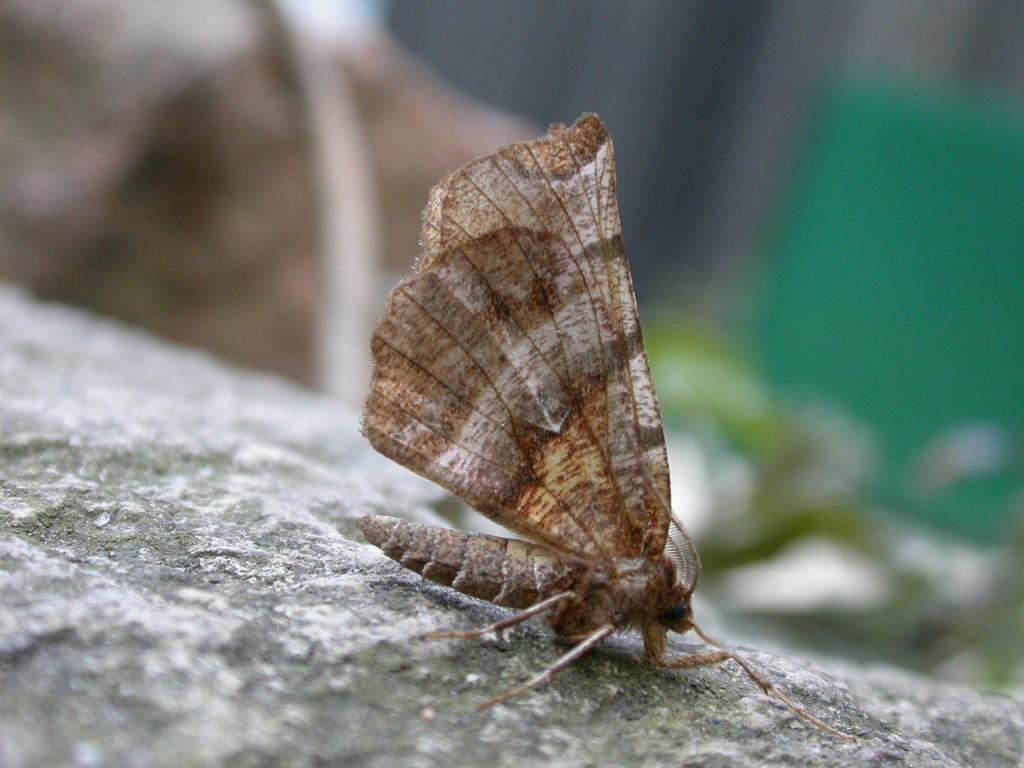Please provide a concise description of this image. There is a butterfly on a surface. The background is blurred. 